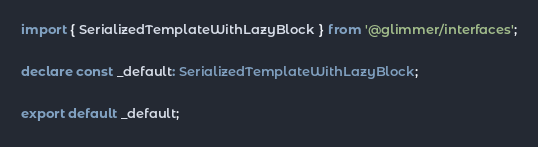<code> <loc_0><loc_0><loc_500><loc_500><_TypeScript_>import { SerializedTemplateWithLazyBlock } from '@glimmer/interfaces';

declare const _default: SerializedTemplateWithLazyBlock;

export default _default;
</code> 